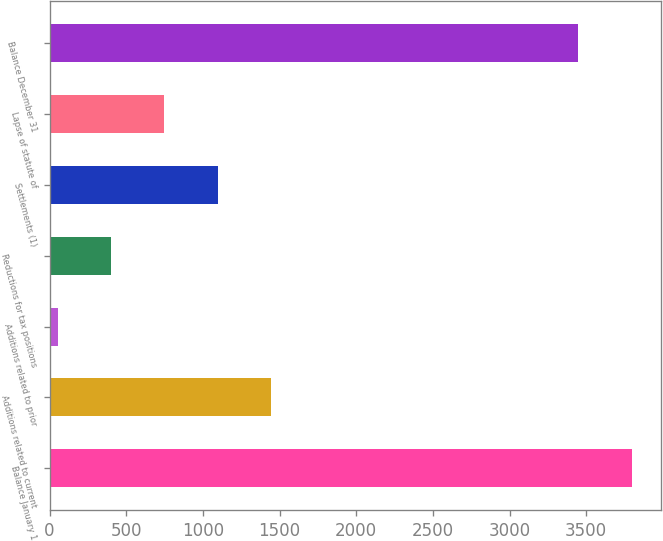Convert chart. <chart><loc_0><loc_0><loc_500><loc_500><bar_chart><fcel>Balance January 1<fcel>Additions related to current<fcel>Additions related to prior<fcel>Reductions for tax positions<fcel>Settlements (1)<fcel>Lapse of statute of<fcel>Balance December 31<nl><fcel>3796.1<fcel>1445.4<fcel>53<fcel>401.1<fcel>1097.3<fcel>749.2<fcel>3448<nl></chart> 